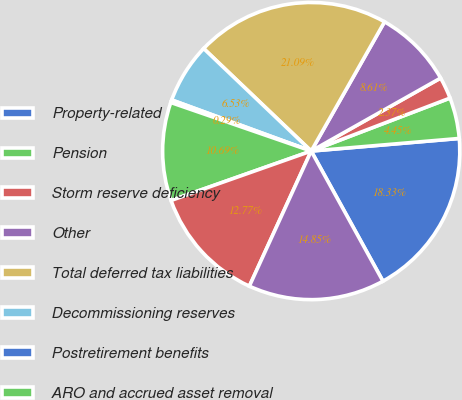<chart> <loc_0><loc_0><loc_500><loc_500><pie_chart><fcel>Property-related<fcel>Pension<fcel>Storm reserve deficiency<fcel>Other<fcel>Total deferred tax liabilities<fcel>Decommissioning reserves<fcel>Postretirement benefits<fcel>ARO and accrued asset removal<fcel>Net deferred tax assets<fcel>Net accumulated deferred<nl><fcel>18.33%<fcel>4.45%<fcel>2.37%<fcel>8.61%<fcel>21.09%<fcel>6.53%<fcel>0.29%<fcel>10.69%<fcel>12.77%<fcel>14.85%<nl></chart> 